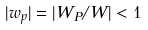Convert formula to latex. <formula><loc_0><loc_0><loc_500><loc_500>| w _ { p } | = | W _ { P } / W | < 1</formula> 